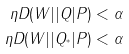<formula> <loc_0><loc_0><loc_500><loc_500>\eta D ( W | | Q | P ) & < \alpha \\ \eta D ( W | | Q _ { ^ { * } } | P ) & < \alpha</formula> 